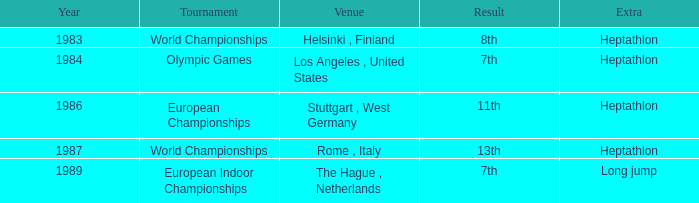At what intervals are the olympic games held? 1984.0. 